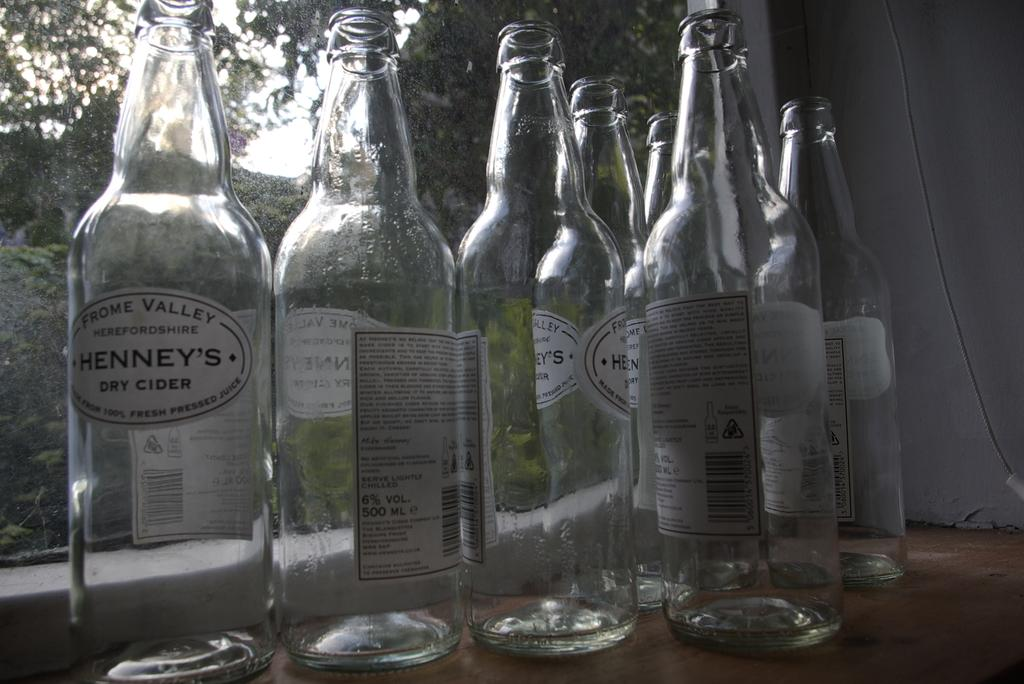What type of bottles are visible in the image? There are empty cider bottles in the image. Where are the bottles located in relation to other objects in the image? The bottles are placed beside a window. What type of root can be seen growing through the window in the image? There is no root visible in the image; it only shows empty cider bottles beside a window. 